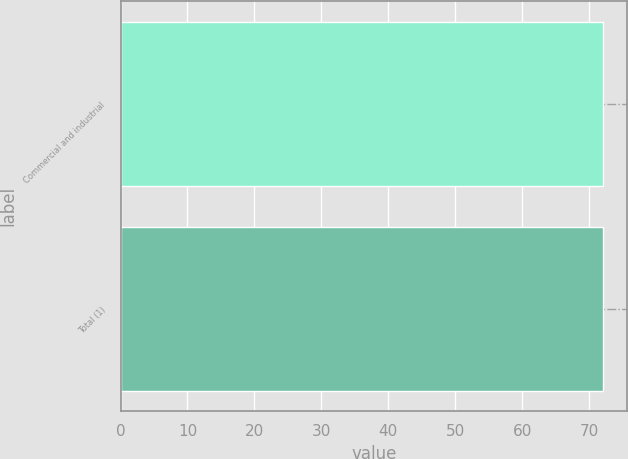Convert chart. <chart><loc_0><loc_0><loc_500><loc_500><bar_chart><fcel>Commercial and industrial<fcel>Total (1)<nl><fcel>72<fcel>72.1<nl></chart> 